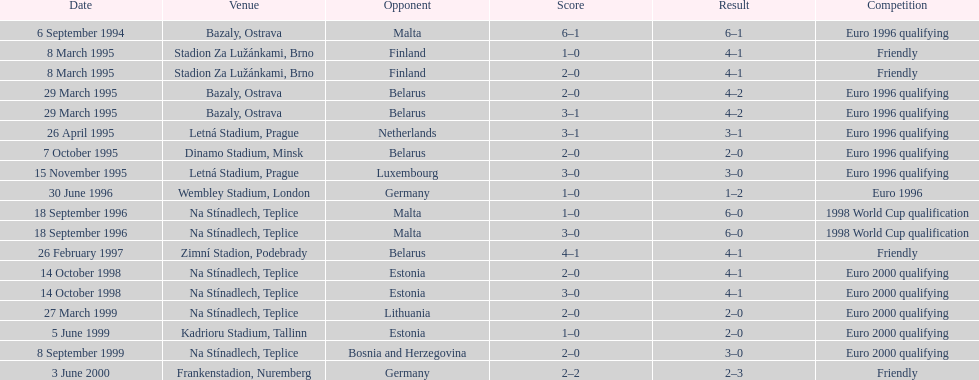Which team did czech republic score the most goals against? Malta. 